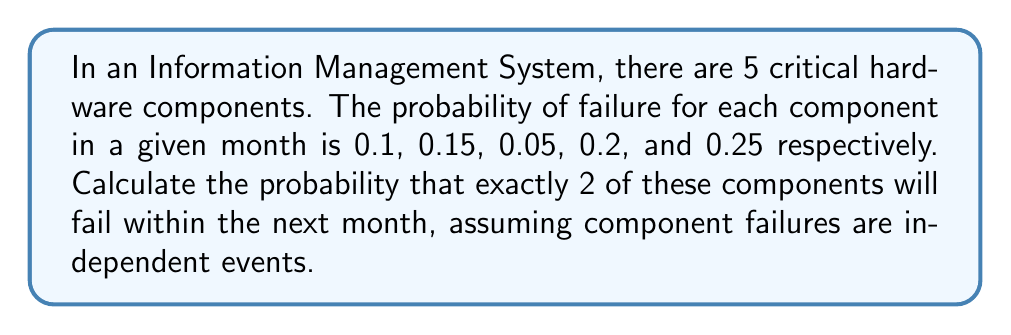Teach me how to tackle this problem. To solve this problem, we'll use the concept of binomial probability. Here's the step-by-step solution:

1) We have 5 components, and we want the probability of exactly 2 failing. This scenario follows a binomial distribution.

2) The probability of success (failure in this case) is different for each component, so we need to calculate the average probability of failure:

   $p_{avg} = \frac{0.1 + 0.15 + 0.05 + 0.2 + 0.25}{5} = 0.15$

3) Now we can use the binomial probability formula:

   $P(X = k) = \binom{n}{k} p^k (1-p)^{n-k}$

   Where:
   $n = 5$ (total number of components)
   $k = 2$ (number of failures we're interested in)
   $p = 0.15$ (average probability of failure)

4) Let's calculate:

   $P(X = 2) = \binom{5}{2} (0.15)^2 (1-0.15)^{5-2}$

5) Expand this:

   $P(X = 2) = 10 \times (0.15)^2 \times (0.85)^3$

6) Calculate:

   $P(X = 2) = 10 \times 0.0225 \times 0.614125 = 0.138178125$

Therefore, the probability of exactly 2 components failing within the next month is approximately 0.1382 or 13.82%.
Answer: 0.1382 